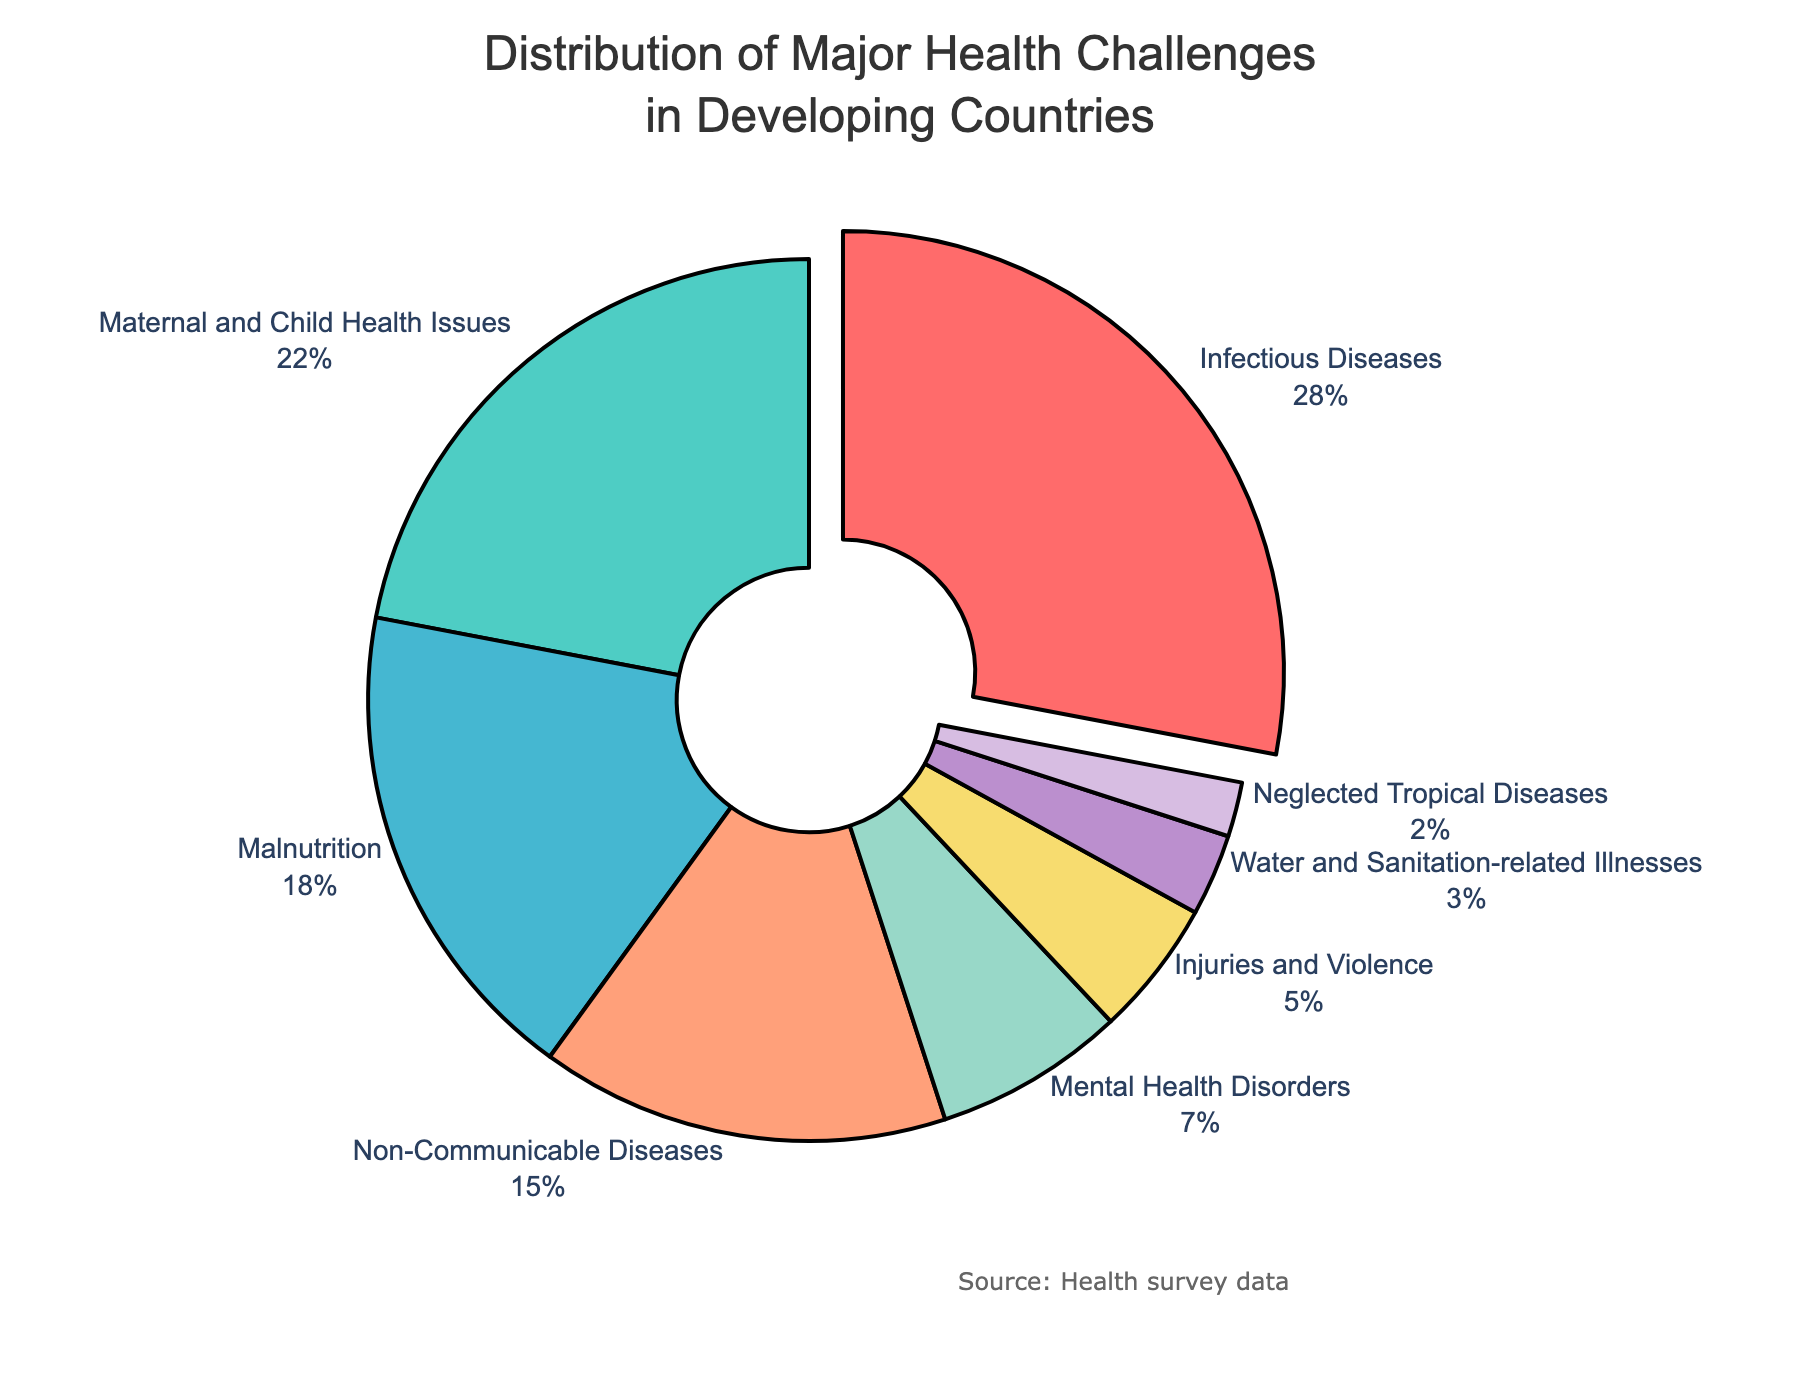What's the largest health challenge according to the pie chart? The pie chart indicates different health challenges and their percentages. The slice pulled out slightly indicates the largest section, which represents Infectious Diseases at 28%.
Answer: Infectious Diseases Which health challenge has the second smallest percentage? By looking at the pie chart, the second smallest slice represents Injuries and Violence at 5%, as the smallest slice is Neglected Tropical Diseases at 2%.
Answer: Injuries and Violence What's the total percentage of Malnutrition and Non-Communicable Diseases combined? From the pie chart, the percentage for Malnutrition is 18% and for Non-Communicable Diseases is 15%. Adding these together, 18% + 15% = 33%.
Answer: 33% Are there more health challenges related to infectious or non-infectious diseases? Infectious diseases include Infectious Diseases (28%), Neglected Tropical Diseases (2%), and Water and Sanitation-related Illnesses (3%), totaling 33%. Non-infectious diseases include Non-Communicable Diseases (15%), Injuries and Violence (5%), and Mental Health Disorders (7%), totaling 27%.
Answer: Infectious Which health challenge is represented by the color green? There is a slice in the pie chart marked with a greenish hue, and the associated label is Maternal and Child Health Issues at 22%.
Answer: Maternal and Child Health Issues What's the difference in percentage between Maternal and Child Health Issues and Mental Health Disorders? Maternal and Child Health Issues have a percentage of 22%, while Mental Health Disorders have 7%. The difference is 22% - 7% = 15%.
Answer: 15% What are the percentages of the top three health challenges? The top three health challenges in the pie chart are Infectious Diseases (28%), Maternal and Child Health Issues (22%), and Malnutrition (18%). Adding these gives 28% + 22% + 18% = 68%.
Answer: 68% How many health challenges have a percentage below 10%? From the pie chart, three health challenges have percentages below 10%: Mental Health Disorders (7%), Injuries and Violence (5%), Water and Sanitation-related Illnesses (3%), and Neglected Tropical Diseases (2%).
Answer: Four 